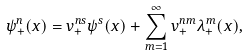Convert formula to latex. <formula><loc_0><loc_0><loc_500><loc_500>\psi ^ { n } _ { + } ( x ) = v ^ { n s } _ { + } \psi ^ { s } ( x ) + \sum ^ { \infty } _ { m = 1 } v ^ { n m } _ { + } \lambda ^ { m } _ { + } ( x ) ,</formula> 